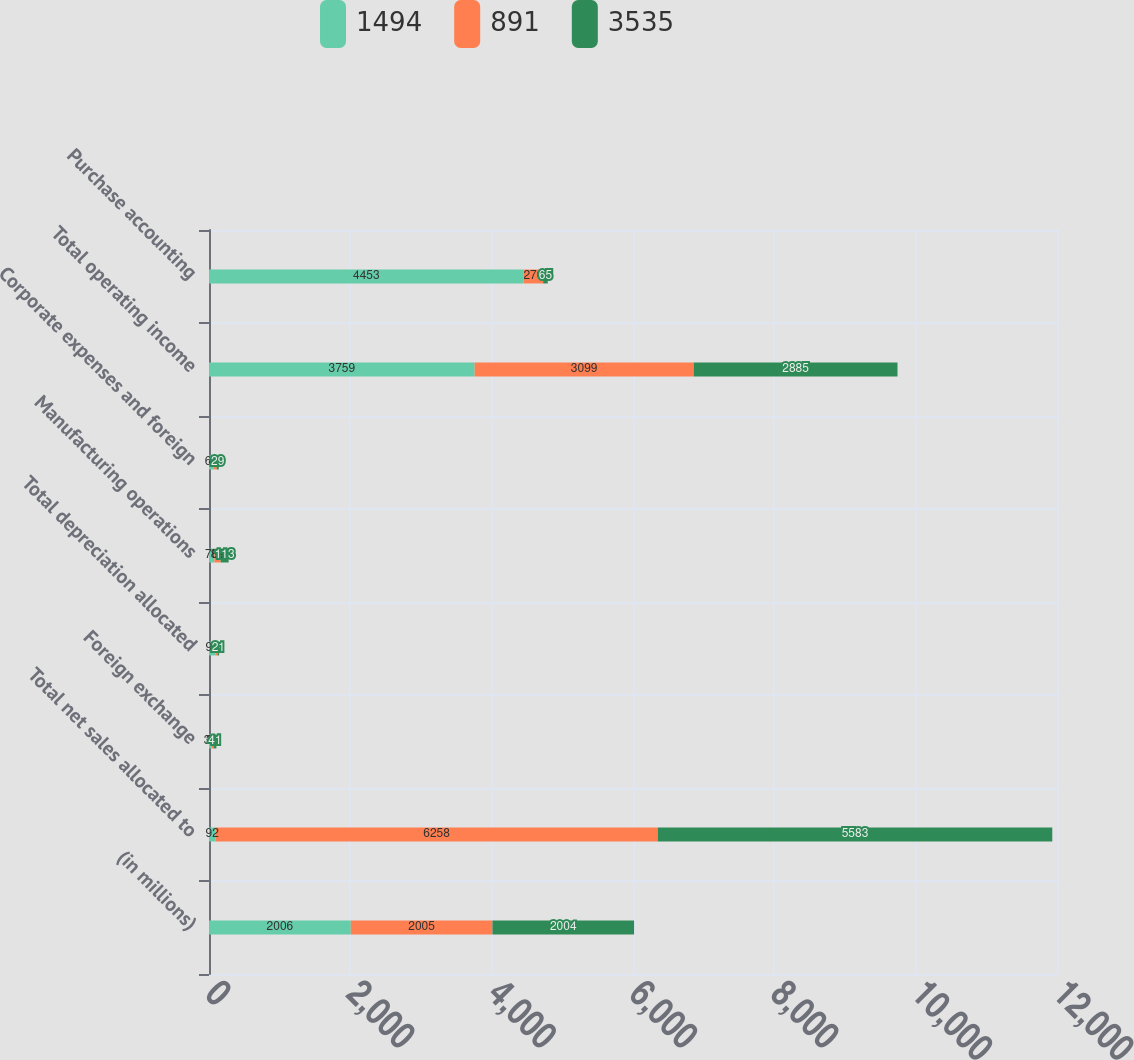Convert chart to OTSL. <chart><loc_0><loc_0><loc_500><loc_500><stacked_bar_chart><ecel><fcel>(in millions)<fcel>Total net sales allocated to<fcel>Foreign exchange<fcel>Total depreciation allocated<fcel>Manufacturing operations<fcel>Corporate expenses and foreign<fcel>Total operating income<fcel>Purchase accounting<nl><fcel>1494<fcel>2006<fcel>92<fcel>39<fcel>92<fcel>76<fcel>66<fcel>3759<fcel>4453<nl><fcel>891<fcel>2005<fcel>6258<fcel>25<fcel>30<fcel>89<fcel>43<fcel>3099<fcel>276<nl><fcel>3535<fcel>2004<fcel>5583<fcel>41<fcel>21<fcel>113<fcel>29<fcel>2885<fcel>65<nl></chart> 